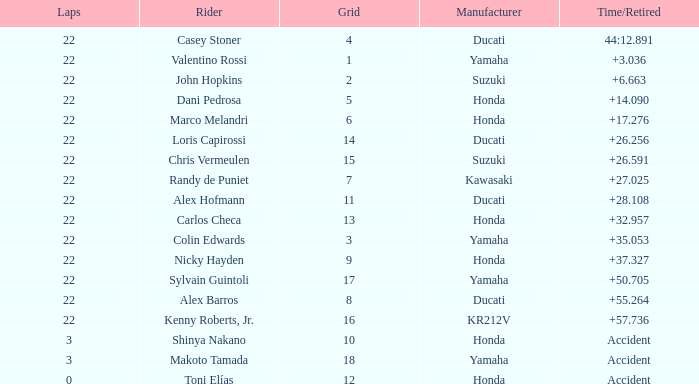What is the average grid for competitors who had more than 22 laps and time/retired of +17.276? None. 